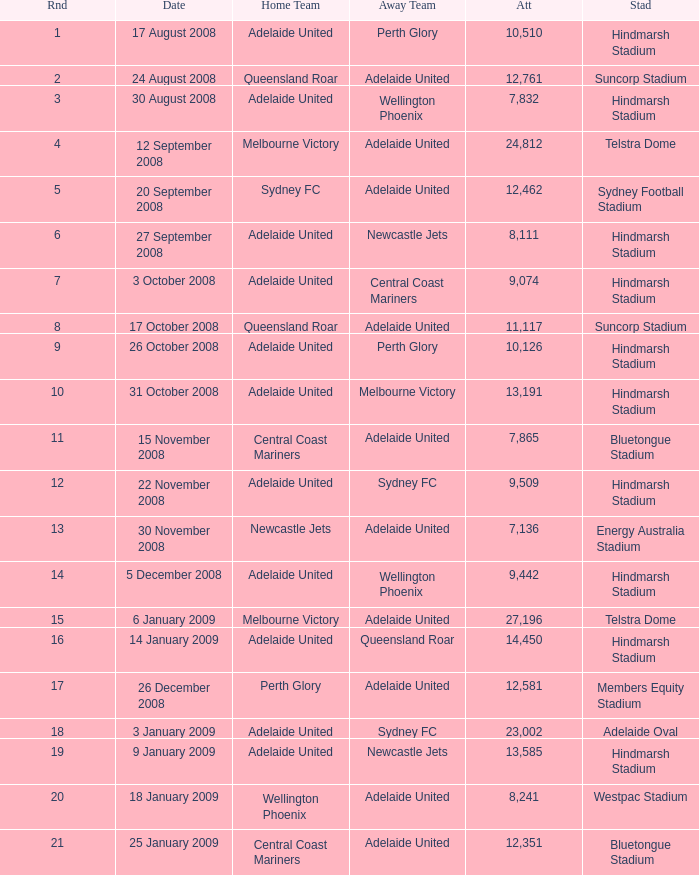What is the round when 11,117 people attended the game on 26 October 2008? 9.0. 